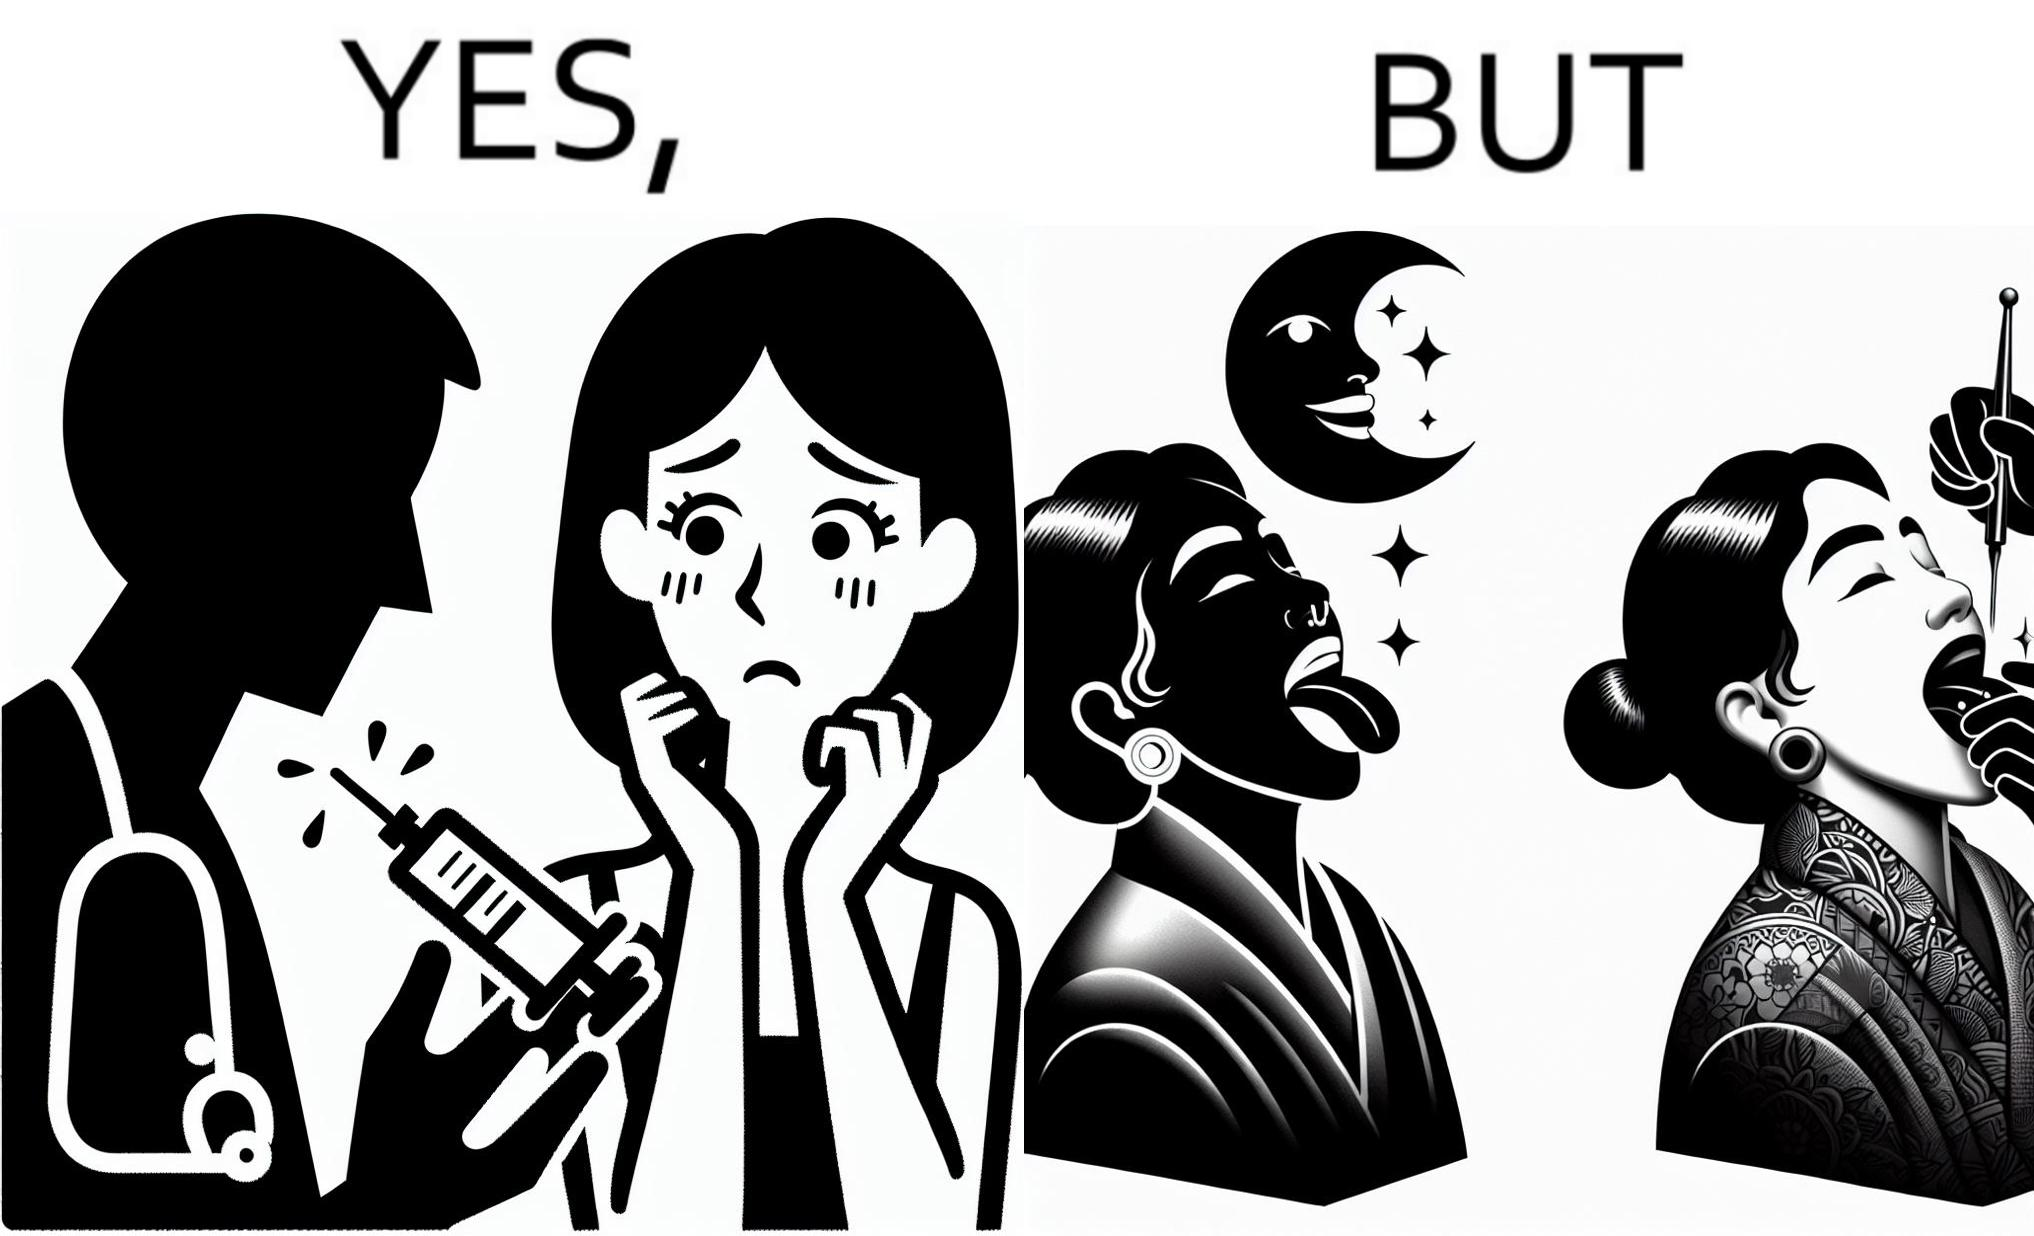Is there satirical content in this image? Yes, this image is satirical. 